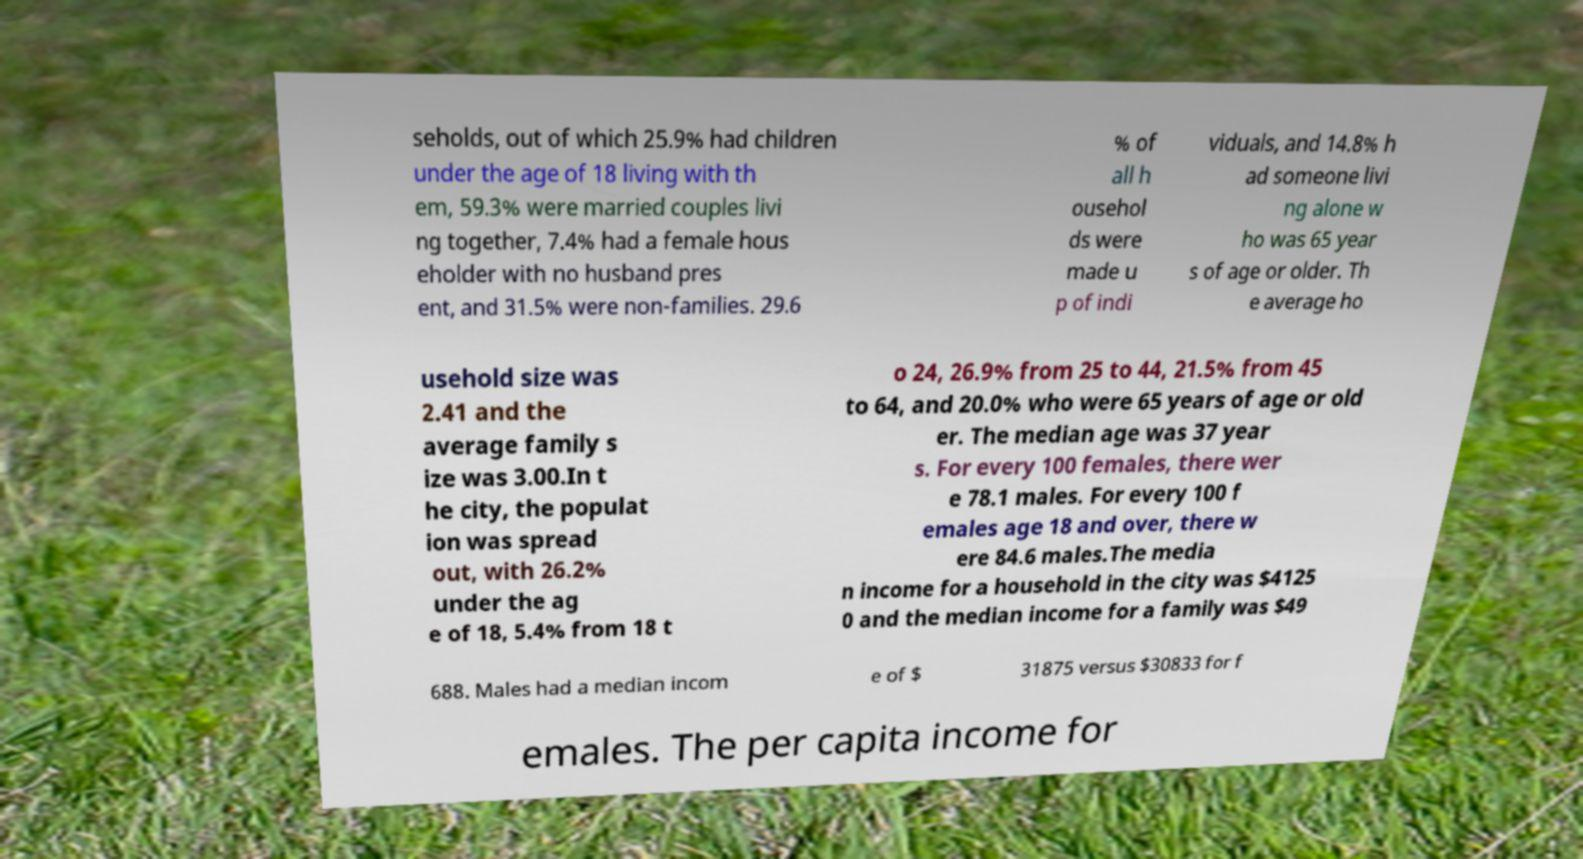For documentation purposes, I need the text within this image transcribed. Could you provide that? seholds, out of which 25.9% had children under the age of 18 living with th em, 59.3% were married couples livi ng together, 7.4% had a female hous eholder with no husband pres ent, and 31.5% were non-families. 29.6 % of all h ousehol ds were made u p of indi viduals, and 14.8% h ad someone livi ng alone w ho was 65 year s of age or older. Th e average ho usehold size was 2.41 and the average family s ize was 3.00.In t he city, the populat ion was spread out, with 26.2% under the ag e of 18, 5.4% from 18 t o 24, 26.9% from 25 to 44, 21.5% from 45 to 64, and 20.0% who were 65 years of age or old er. The median age was 37 year s. For every 100 females, there wer e 78.1 males. For every 100 f emales age 18 and over, there w ere 84.6 males.The media n income for a household in the city was $4125 0 and the median income for a family was $49 688. Males had a median incom e of $ 31875 versus $30833 for f emales. The per capita income for 